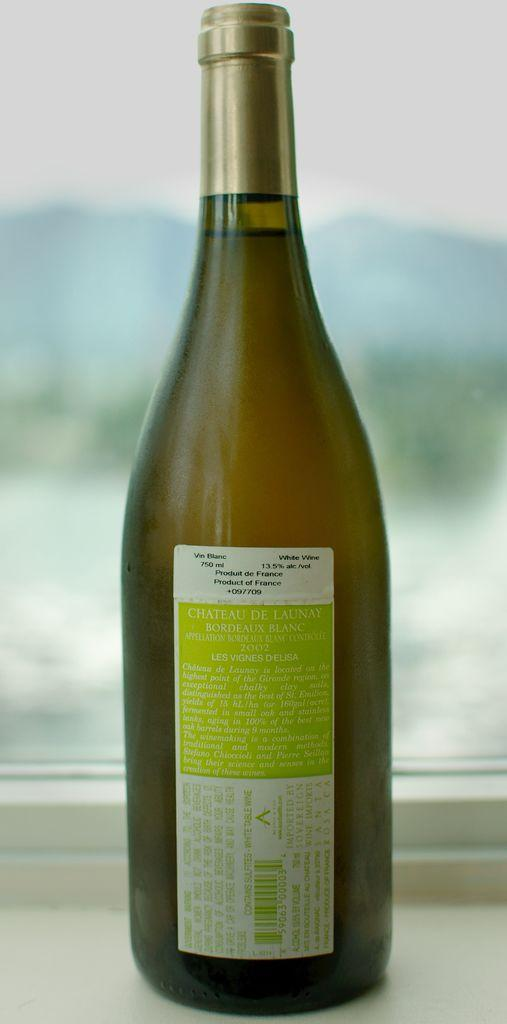<image>
Present a compact description of the photo's key features. A bottle of French white wine from Chateau De Launay. 